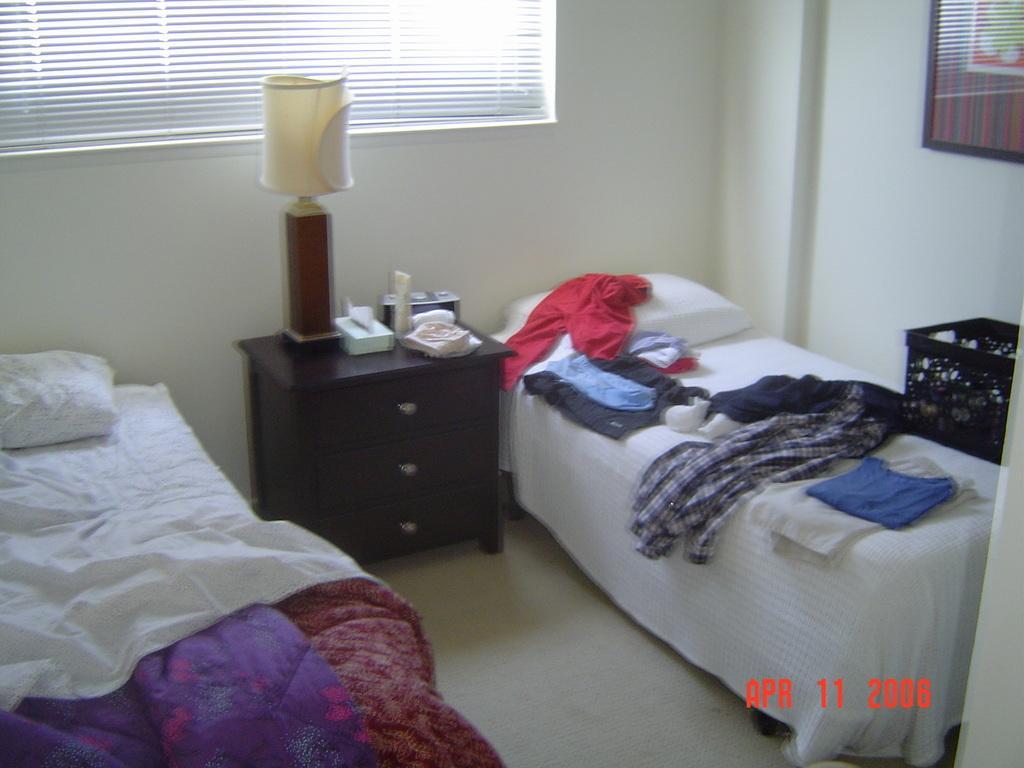How would you summarize this image in a sentence or two? In this image we can see group of clothes and pillows placed on beds. In the center of the image we can see a lamp and some objects placed on cupboards. On the right side of the image we can see a basket. In the background, we can see a photo frame on the wall and window with curtain. 